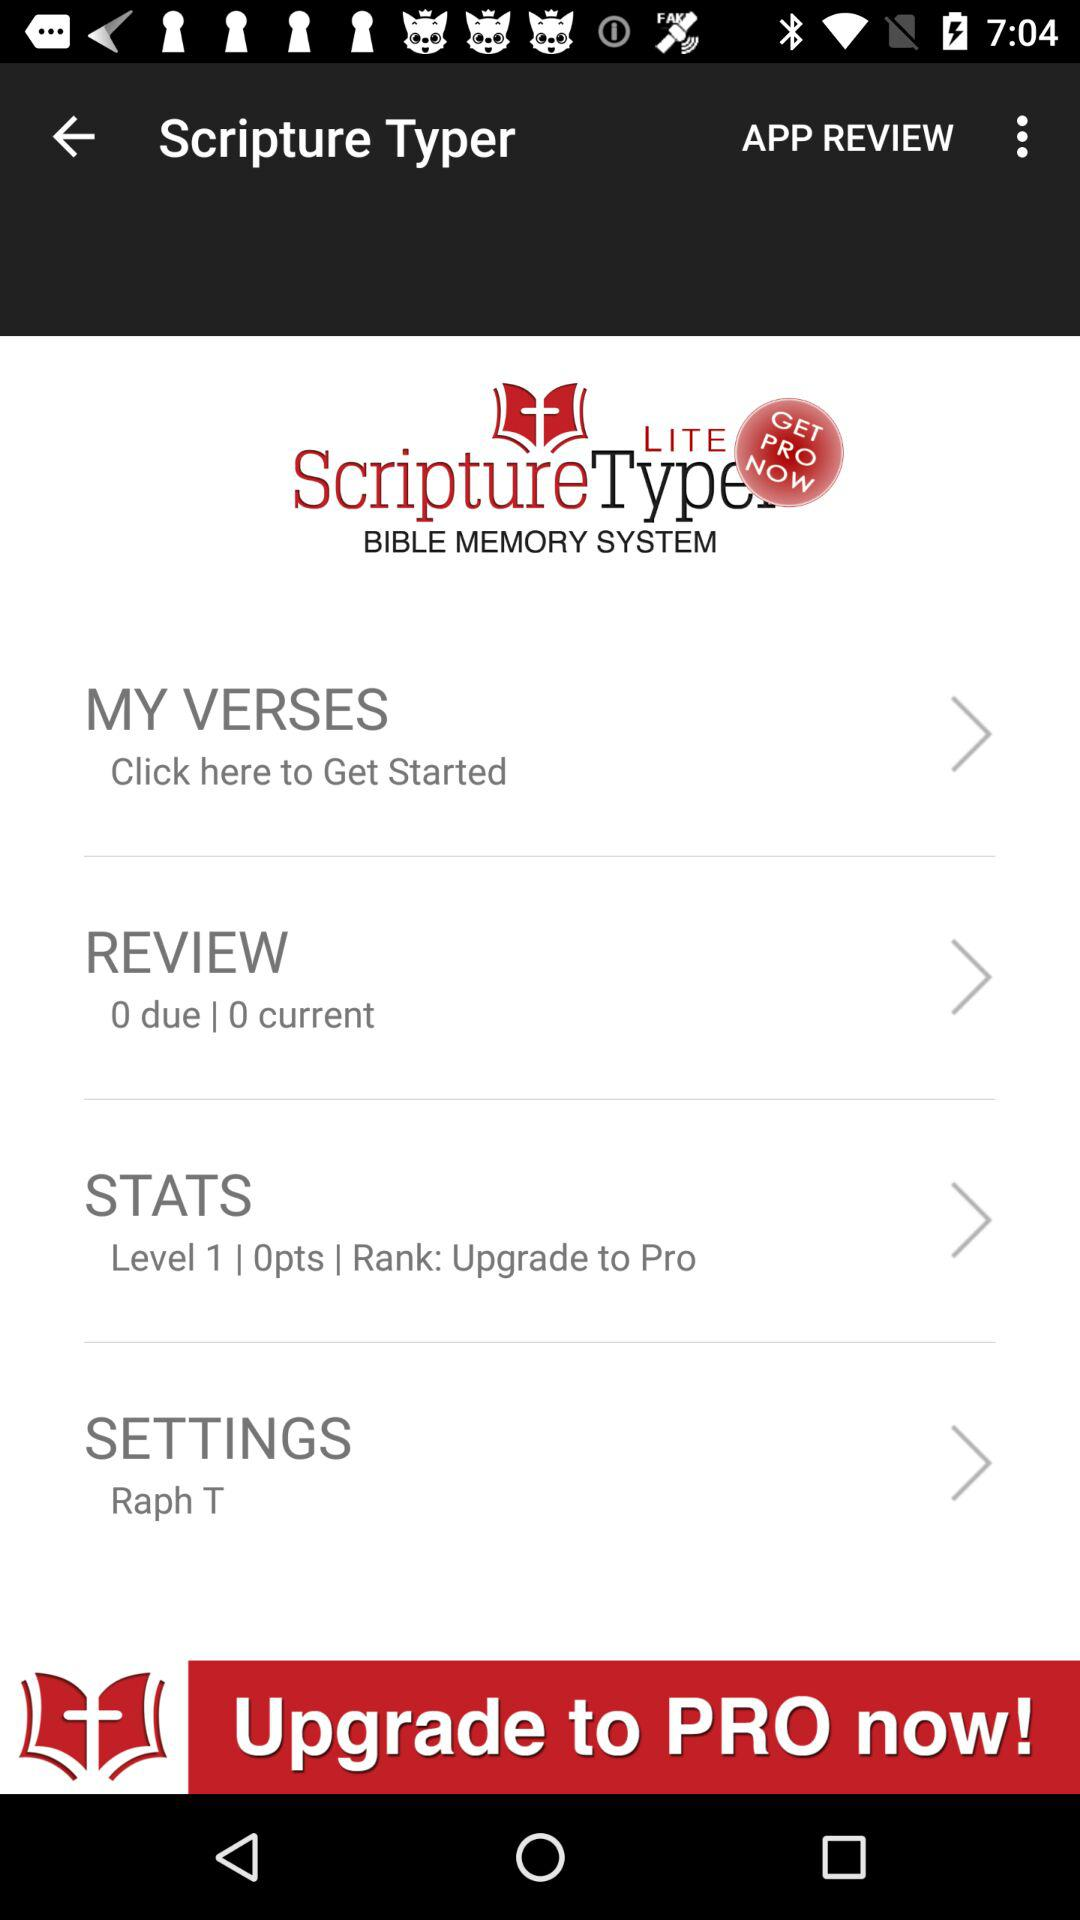What is the number of points? The number of points is 0. 